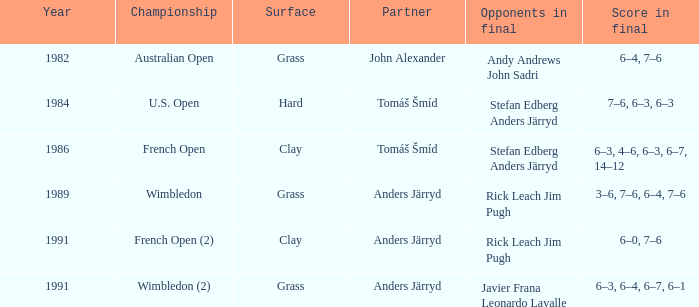What was the final score in 1986? 6–3, 4–6, 6–3, 6–7, 14–12. 